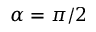<formula> <loc_0><loc_0><loc_500><loc_500>\alpha = \pi / 2</formula> 